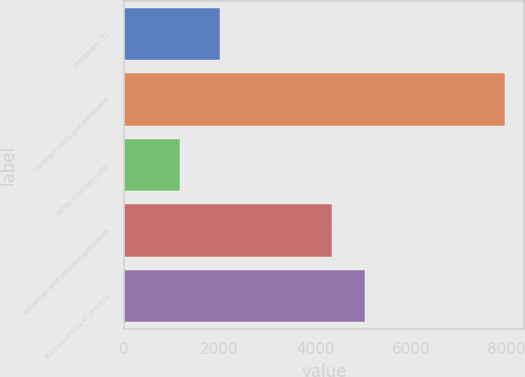<chart> <loc_0><loc_0><loc_500><loc_500><bar_chart><fcel>December 31<fcel>Contract costs and estimated<fcel>Other contract costs<fcel>Advances and progress payments<fcel>Total contracts in process<nl><fcel>2013<fcel>7961<fcel>1178<fcel>4359<fcel>5037.3<nl></chart> 